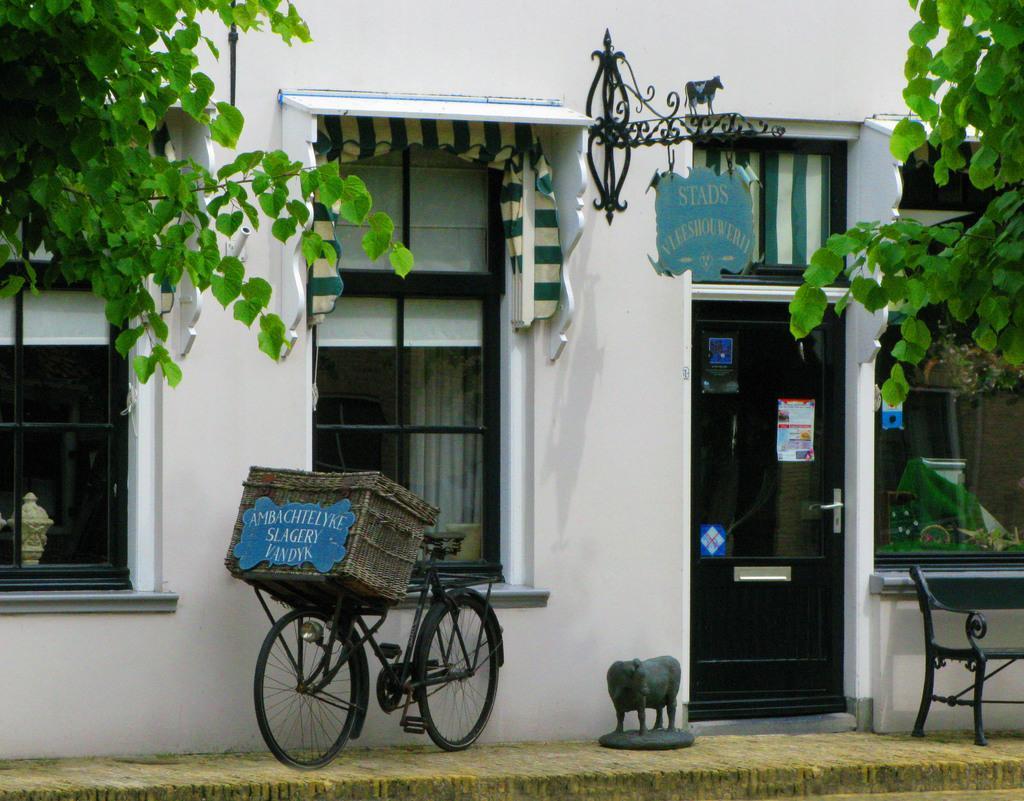How would you summarize this image in a sentence or two? In this picture we can observe a bicycle which is in black color. There is grey color box on the bicycle. We can observe a statue of an animal in front of the wall which is in white color. We can observe windows and trees. There is a black color door. 